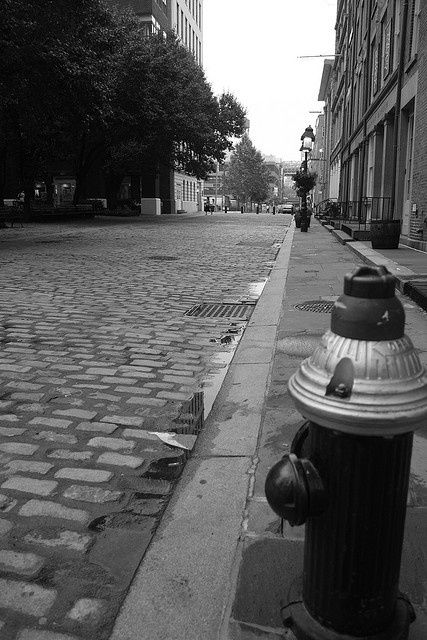Describe the objects in this image and their specific colors. I can see a fire hydrant in black, gray, darkgray, and lightgray tones in this image. 